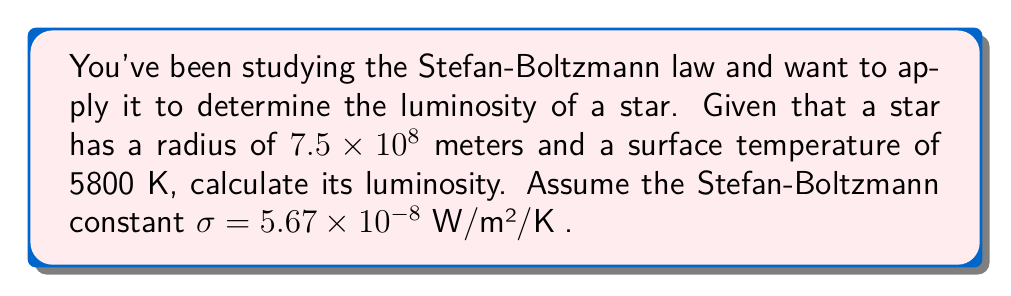Can you answer this question? To solve this problem, we'll use the Stefan-Boltzmann law, which relates the luminosity of a star to its radius and surface temperature. The steps are as follows:

1) The Stefan-Boltzmann law is given by:

   $$L = 4\pi R^2 \sigma T^4$$

   Where:
   $L$ is the luminosity in watts (W)
   $R$ is the radius of the star in meters (m)
   $\sigma$ is the Stefan-Boltzmann constant (W/m²/K⁴)
   $T$ is the surface temperature of the star in Kelvin (K)

2) We have the following values:
   $R = 7.5 \times 10^8$ m
   $T = 5800$ K
   $\sigma = 5.67 \times 10^{-8}$ W/m²/K⁴

3) Let's substitute these values into the equation:

   $$L = 4\pi (7.5 \times 10^8 \text{ m})^2 \times (5.67 \times 10^{-8} \text{ W/m²/K⁴}) \times (5800 \text{ K})^4$$

4) Now, let's calculate step by step:
   - First, calculate $R^2$: $(7.5 \times 10^8)^2 = 5.625 \times 10^{17}$
   - Then, $T^4$: $5800^4 = 1.1316 \times 10^{15}$
   - Multiply all parts:
     $$L = 4\pi \times 5.625 \times 10^{17} \times 5.67 \times 10^{-8} \times 1.1316 \times 10^{15}$$

5) Simplify:
   $$L = 4 \times 3.14159 \times 5.625 \times 5.67 \times 1.1316 \times 10^{17-8+15} = 4.531 \times 10^{26} \text{ W}$$

Therefore, the luminosity of the star is approximately $4.531 \times 10^{26}$ watts.
Answer: $4.531 \times 10^{26}$ W 